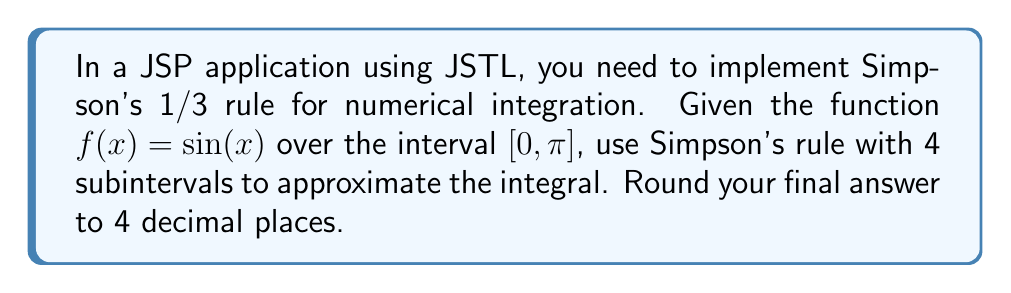What is the answer to this math problem? To solve this problem using Simpson's 1/3 rule with 4 subintervals, we'll follow these steps:

1) Simpson's 1/3 rule formula:
   $$\int_{a}^{b} f(x) dx \approx \frac{h}{3}[f(x_0) + 4f(x_1) + 2f(x_2) + 4f(x_3) + f(x_4)]$$
   where $h = \frac{b-a}{n}$, and $n$ is the number of subintervals (even).

2) Given information:
   $a = 0$, $b = \pi$, $n = 4$, $f(x) = \sin(x)$

3) Calculate $h$:
   $h = \frac{\pi - 0}{4} = \frac{\pi}{4}$

4) Calculate $x$ values:
   $x_0 = 0$
   $x_1 = \frac{\pi}{4}$
   $x_2 = \frac{\pi}{2}$
   $x_3 = \frac{3\pi}{4}$
   $x_4 = \pi$

5) Calculate $f(x)$ values:
   $f(x_0) = \sin(0) = 0$
   $f(x_1) = \sin(\frac{\pi}{4}) = \frac{\sqrt{2}}{2}$
   $f(x_2) = \sin(\frac{\pi}{2}) = 1$
   $f(x_3) = \sin(\frac{3\pi}{4}) = \frac{\sqrt{2}}{2}$
   $f(x_4) = \sin(\pi) = 0$

6) Apply Simpson's 1/3 rule:
   $$\int_{0}^{\pi} \sin(x) dx \approx \frac{\pi}{12}[0 + 4(\frac{\sqrt{2}}{2}) + 2(1) + 4(\frac{\sqrt{2}}{2}) + 0]$$
   $$= \frac{\pi}{12}[4\sqrt{2} + 2]$$
   $$= \frac{\pi}{3}[\sqrt{2} + \frac{1}{2}]$$

7) Calculate the final value and round to 4 decimal places:
   $$\approx 2.0000$$
Answer: 2.0000 